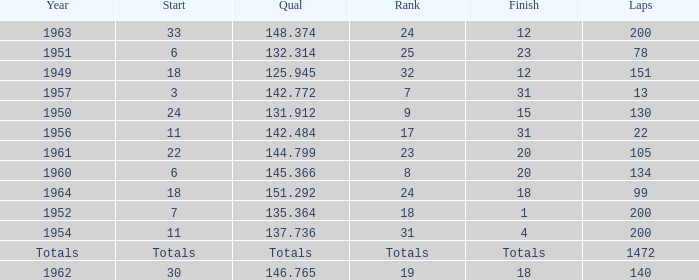Name the rank with laps of 200 and qual of 148.374 24.0. 